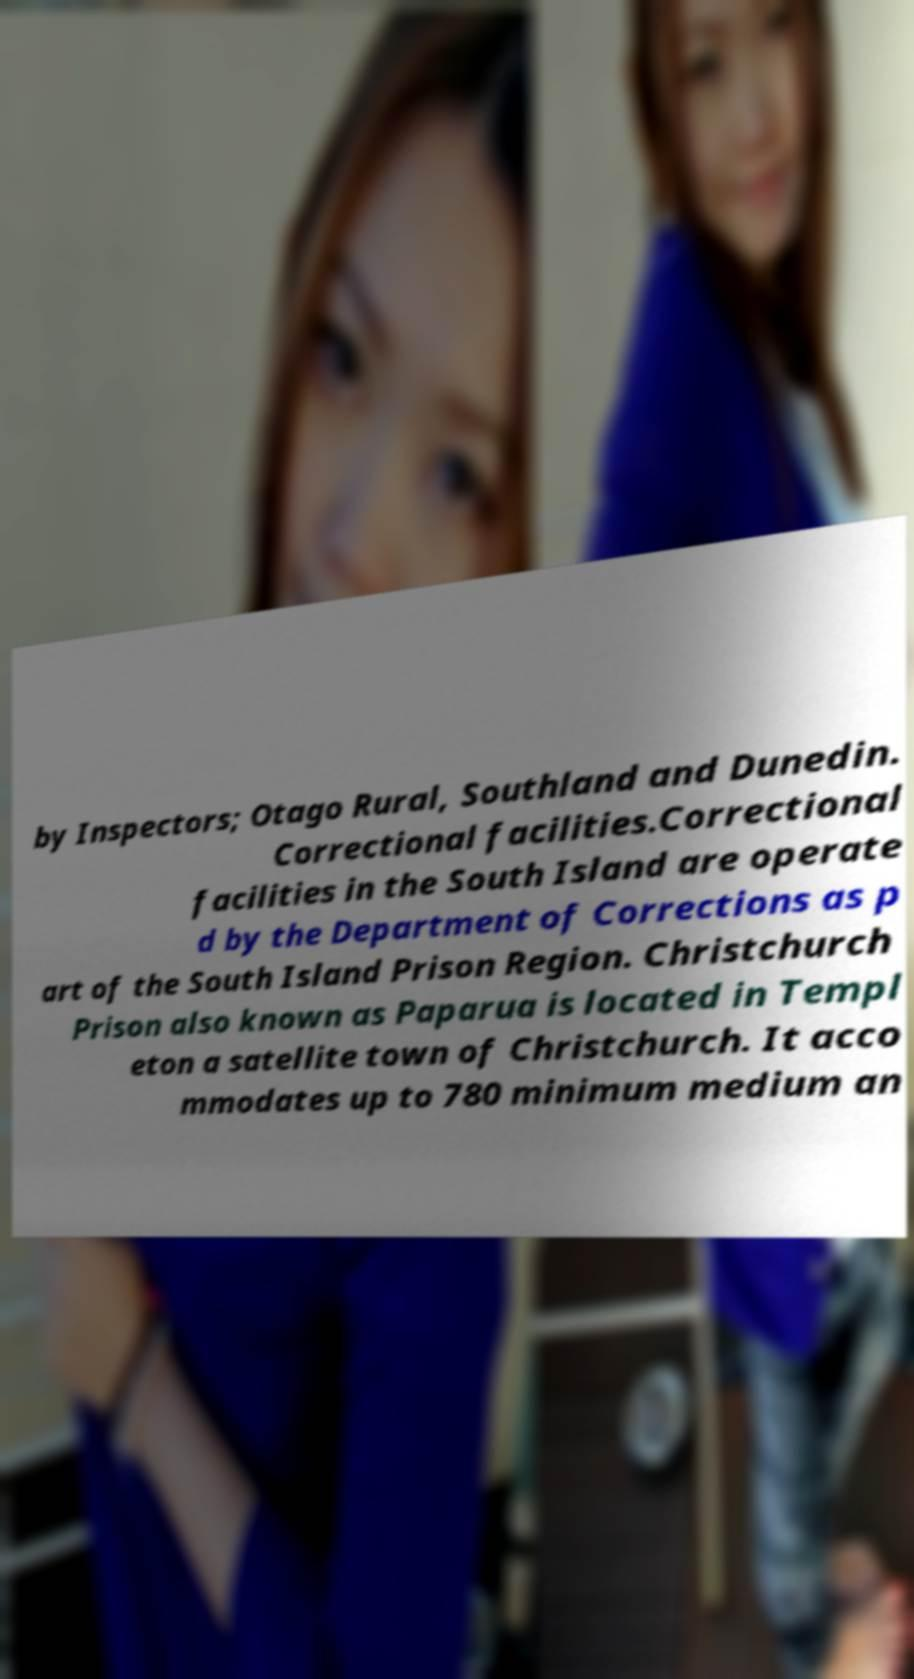Please identify and transcribe the text found in this image. by Inspectors; Otago Rural, Southland and Dunedin. Correctional facilities.Correctional facilities in the South Island are operate d by the Department of Corrections as p art of the South Island Prison Region. Christchurch Prison also known as Paparua is located in Templ eton a satellite town of Christchurch. It acco mmodates up to 780 minimum medium an 